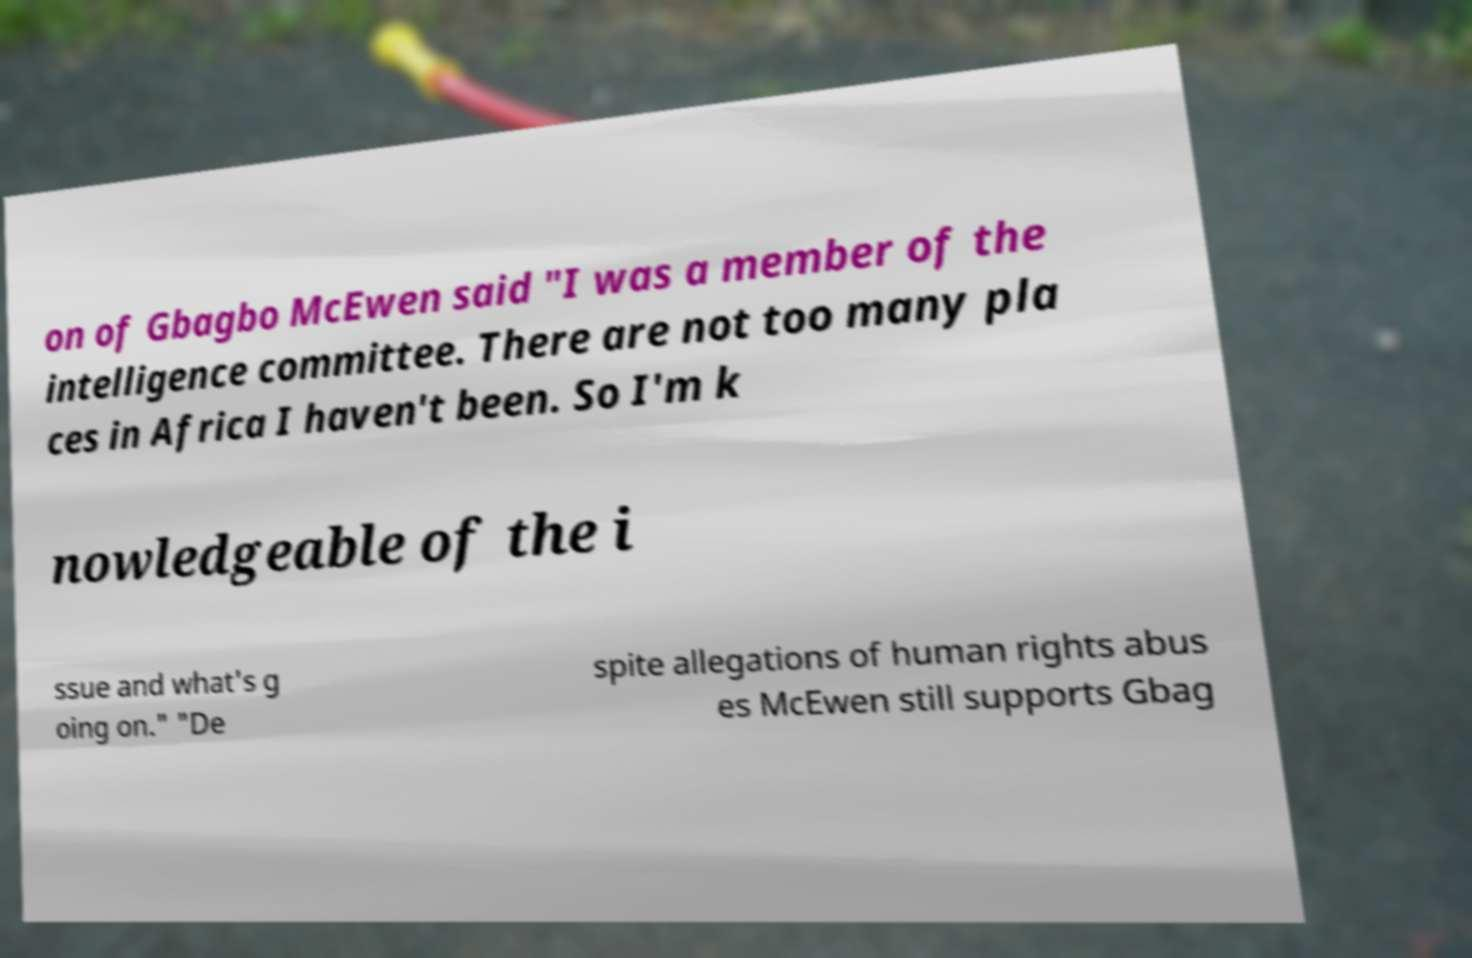What messages or text are displayed in this image? I need them in a readable, typed format. on of Gbagbo McEwen said "I was a member of the intelligence committee. There are not too many pla ces in Africa I haven't been. So I'm k nowledgeable of the i ssue and what's g oing on." "De spite allegations of human rights abus es McEwen still supports Gbag 